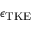Convert formula to latex. <formula><loc_0><loc_0><loc_500><loc_500>\epsilon _ { T K E }</formula> 